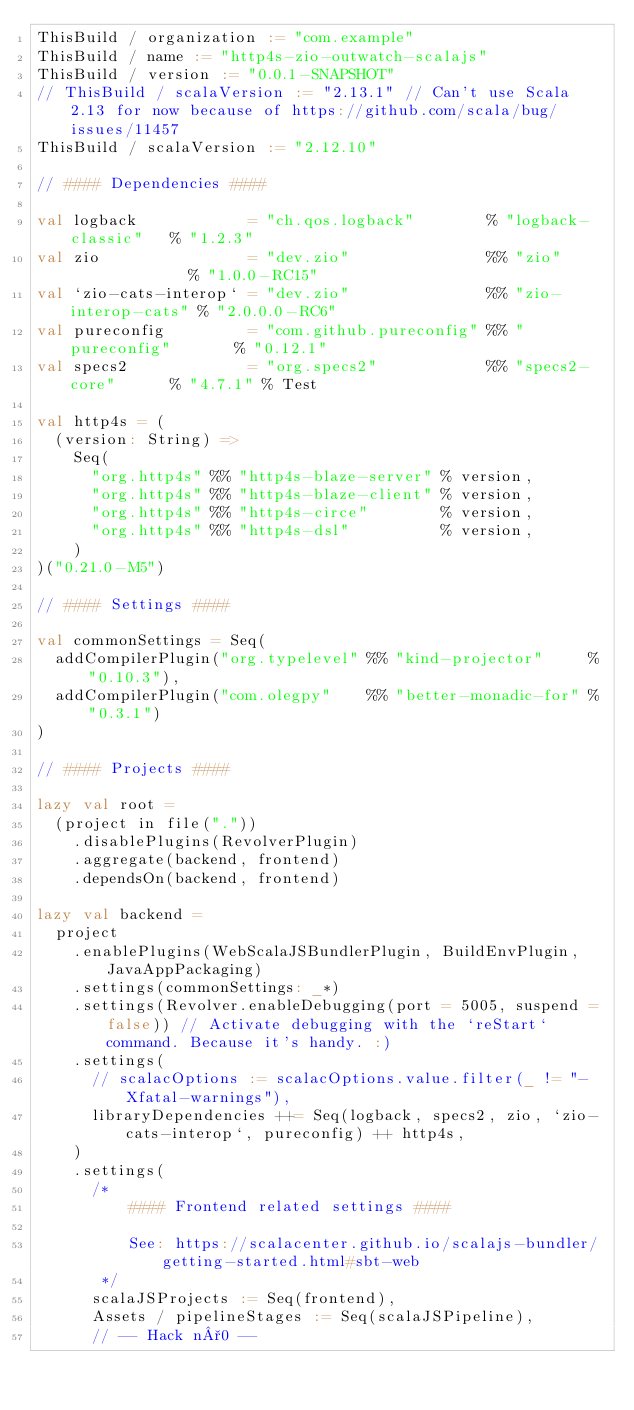<code> <loc_0><loc_0><loc_500><loc_500><_Scala_>ThisBuild / organization := "com.example"
ThisBuild / name := "http4s-zio-outwatch-scalajs"
ThisBuild / version := "0.0.1-SNAPSHOT"
// ThisBuild / scalaVersion := "2.13.1" // Can't use Scala 2.13 for now because of https://github.com/scala/bug/issues/11457
ThisBuild / scalaVersion := "2.12.10"

// #### Dependencies ####

val logback            = "ch.qos.logback"        % "logback-classic"   % "1.2.3"
val zio                = "dev.zio"               %% "zio"              % "1.0.0-RC15"
val `zio-cats-interop` = "dev.zio"               %% "zio-interop-cats" % "2.0.0.0-RC6"
val pureconfig         = "com.github.pureconfig" %% "pureconfig"       % "0.12.1"
val specs2             = "org.specs2"            %% "specs2-core"      % "4.7.1" % Test

val http4s = (
  (version: String) =>
    Seq(
      "org.http4s" %% "http4s-blaze-server" % version,
      "org.http4s" %% "http4s-blaze-client" % version,
      "org.http4s" %% "http4s-circe"        % version,
      "org.http4s" %% "http4s-dsl"          % version,
    )
)("0.21.0-M5")

// #### Settings ####

val commonSettings = Seq(
  addCompilerPlugin("org.typelevel" %% "kind-projector"     % "0.10.3"),
  addCompilerPlugin("com.olegpy"    %% "better-monadic-for" % "0.3.1")
)

// #### Projects ####

lazy val root =
  (project in file("."))
    .disablePlugins(RevolverPlugin)
    .aggregate(backend, frontend)
    .dependsOn(backend, frontend)

lazy val backend =
  project
    .enablePlugins(WebScalaJSBundlerPlugin, BuildEnvPlugin, JavaAppPackaging)
    .settings(commonSettings: _*)
    .settings(Revolver.enableDebugging(port = 5005, suspend = false)) // Activate debugging with the `reStart` command. Because it's handy. :)
    .settings(
      // scalacOptions := scalacOptions.value.filter(_ != "-Xfatal-warnings"),
      libraryDependencies ++= Seq(logback, specs2, zio, `zio-cats-interop`, pureconfig) ++ http4s,
    )
    .settings(
      /*
          #### Frontend related settings ####

          See: https://scalacenter.github.io/scalajs-bundler/getting-started.html#sbt-web
       */
      scalaJSProjects := Seq(frontend),
      Assets / pipelineStages := Seq(scalaJSPipeline),
      // -- Hack n°0 --</code> 